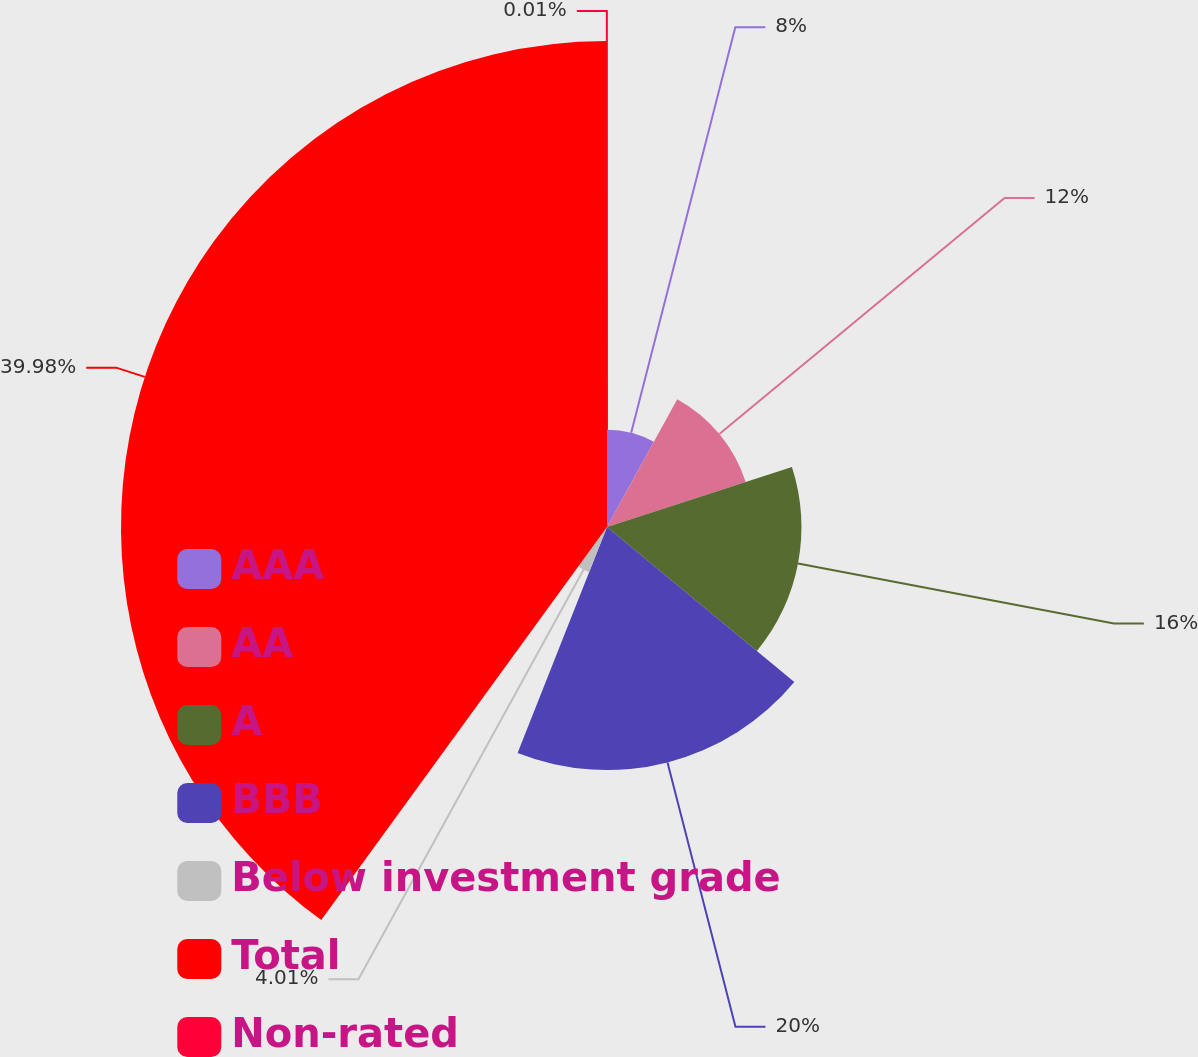Convert chart to OTSL. <chart><loc_0><loc_0><loc_500><loc_500><pie_chart><fcel>AAA<fcel>AA<fcel>A<fcel>BBB<fcel>Below investment grade<fcel>Total<fcel>Non-rated<nl><fcel>8.0%<fcel>12.0%<fcel>16.0%<fcel>20.0%<fcel>4.01%<fcel>39.99%<fcel>0.01%<nl></chart> 